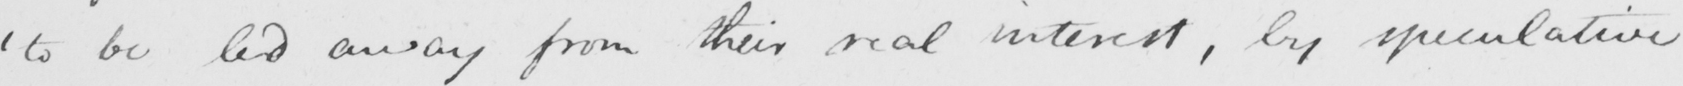What text is written in this handwritten line? ' to be led away from their real interest , by speculative 